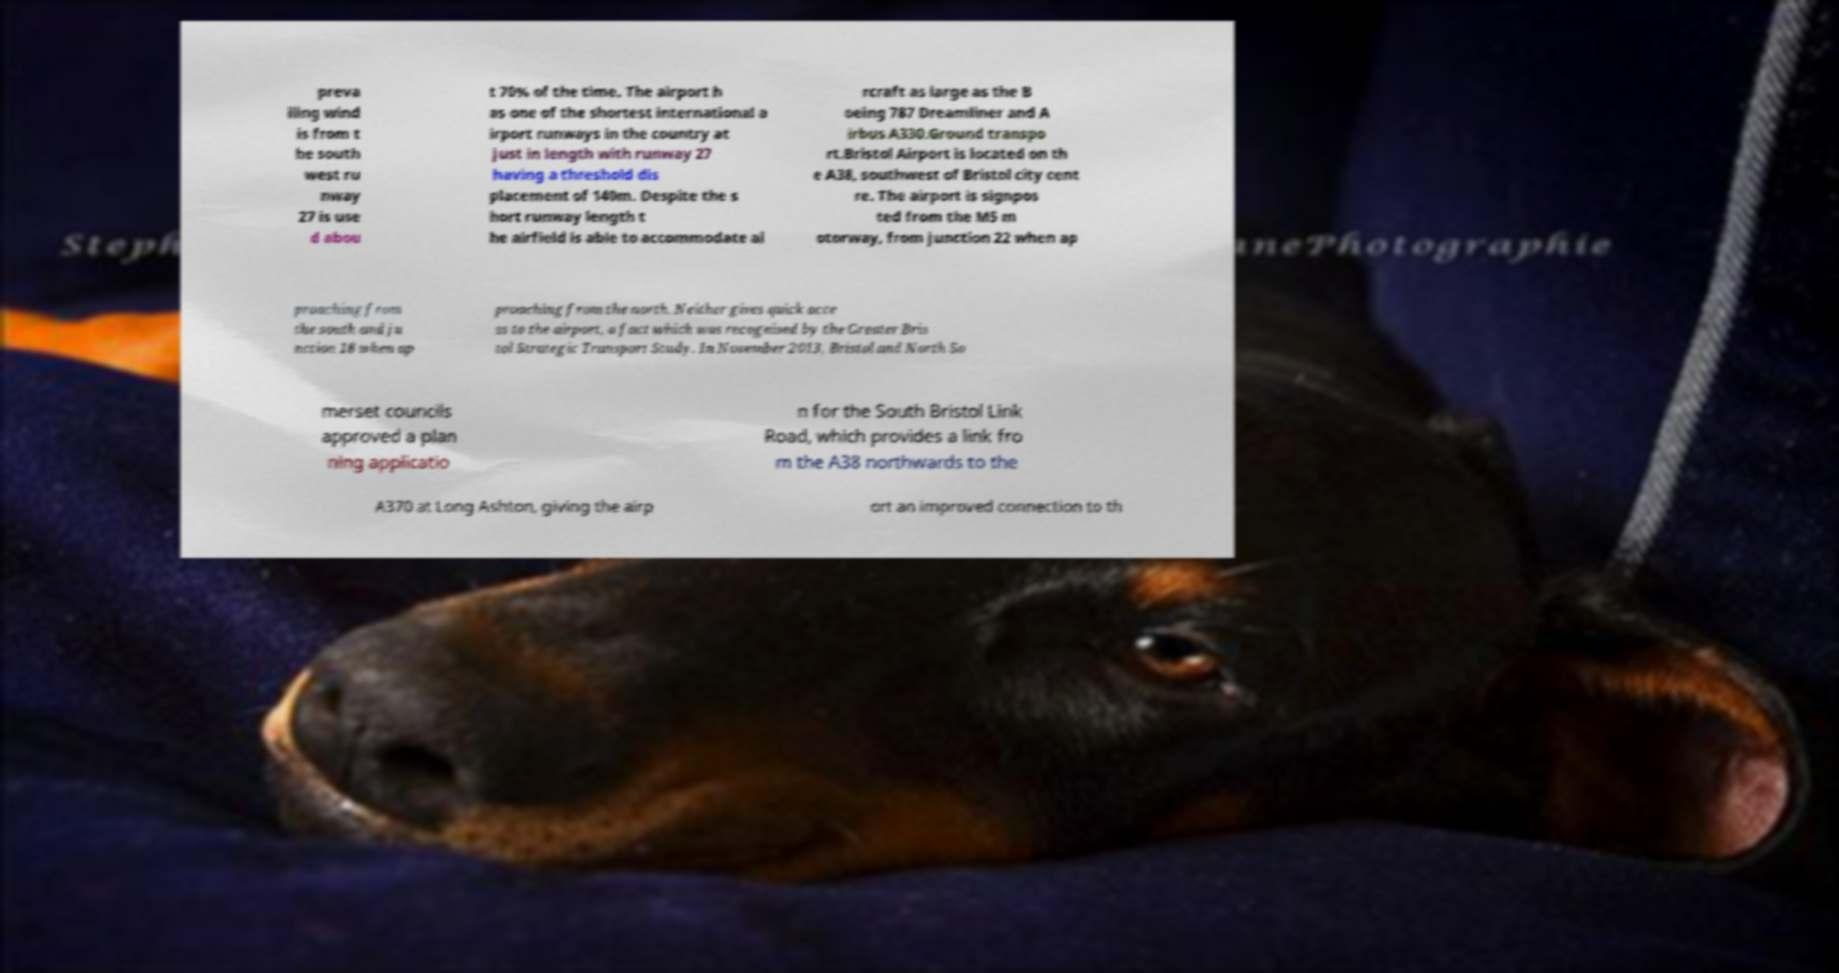Please read and relay the text visible in this image. What does it say? preva iling wind is from t he south west ru nway 27 is use d abou t 70% of the time. The airport h as one of the shortest international a irport runways in the country at just in length with runway 27 having a threshold dis placement of 140m. Despite the s hort runway length t he airfield is able to accommodate ai rcraft as large as the B oeing 787 Dreamliner and A irbus A330.Ground transpo rt.Bristol Airport is located on th e A38, southwest of Bristol city cent re. The airport is signpos ted from the M5 m otorway, from junction 22 when ap proaching from the south and ju nction 18 when ap proaching from the north. Neither gives quick acce ss to the airport, a fact which was recognised by the Greater Bris tol Strategic Transport Study. In November 2013, Bristol and North So merset councils approved a plan ning applicatio n for the South Bristol Link Road, which provides a link fro m the A38 northwards to the A370 at Long Ashton, giving the airp ort an improved connection to th 